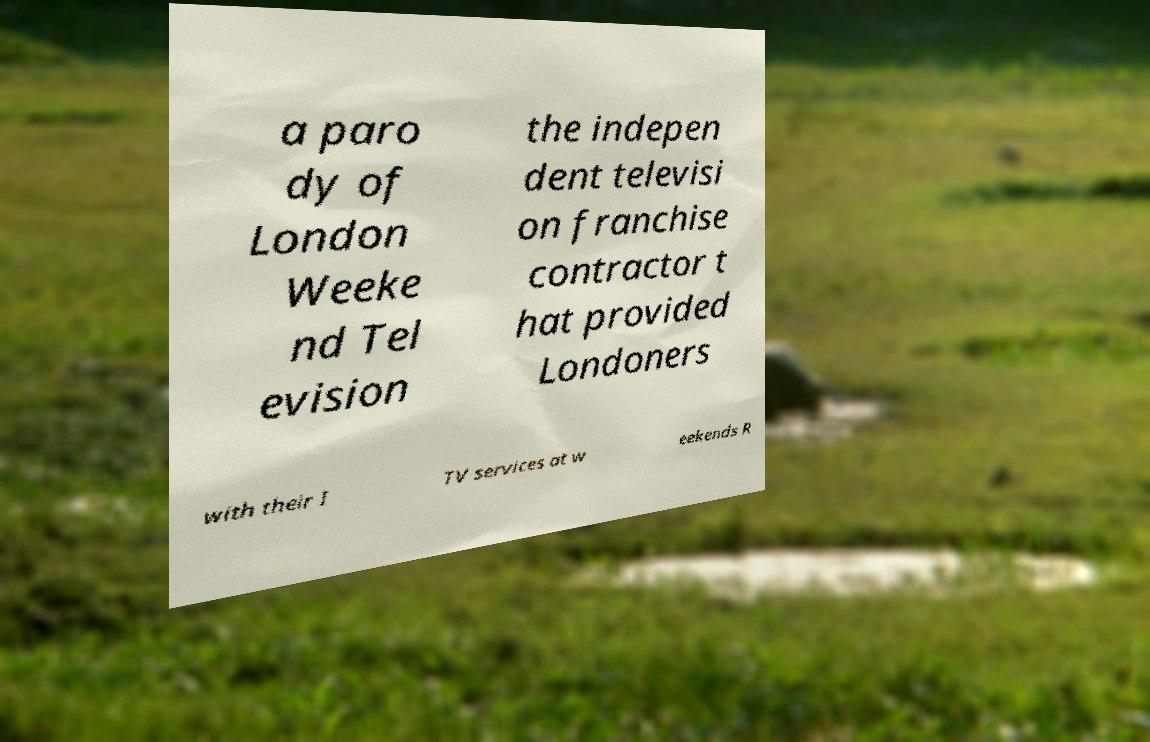Could you extract and type out the text from this image? a paro dy of London Weeke nd Tel evision the indepen dent televisi on franchise contractor t hat provided Londoners with their I TV services at w eekends R 